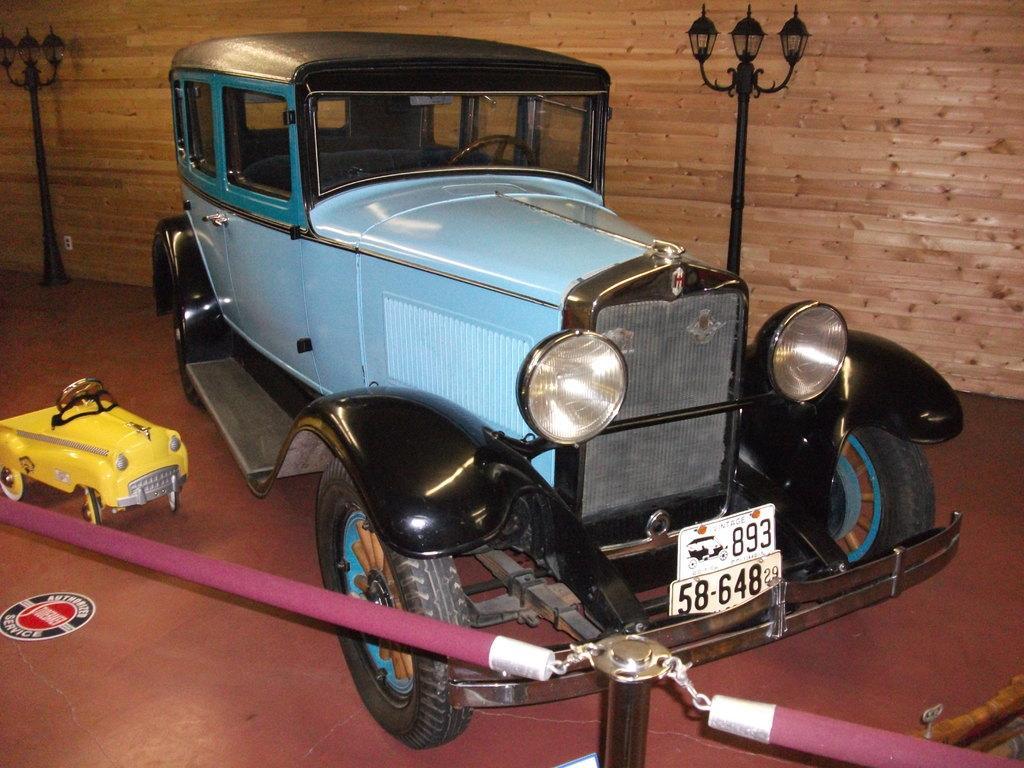Could you give a brief overview of what you see in this image? In this image there is a vehicle and a toy are on the floor. Bottom of the image there is a fence. Behind the vehicle, there is a street light. Background there is a wooden wall. Left side there is a street light on the floor. 